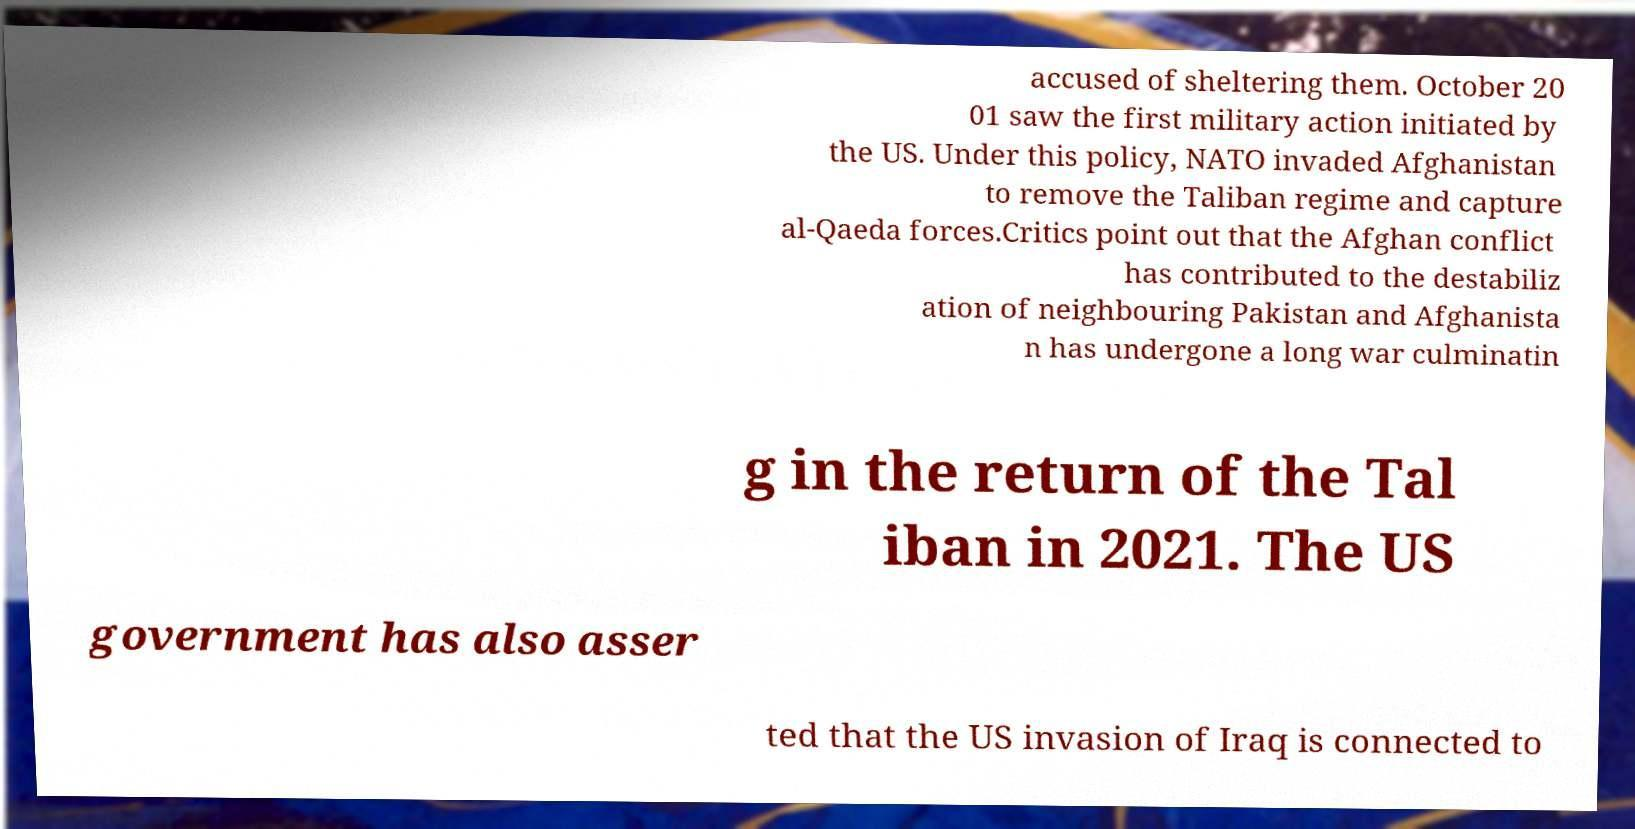For documentation purposes, I need the text within this image transcribed. Could you provide that? accused of sheltering them. October 20 01 saw the first military action initiated by the US. Under this policy, NATO invaded Afghanistan to remove the Taliban regime and capture al-Qaeda forces.Critics point out that the Afghan conflict has contributed to the destabiliz ation of neighbouring Pakistan and Afghanista n has undergone a long war culminatin g in the return of the Tal iban in 2021. The US government has also asser ted that the US invasion of Iraq is connected to 